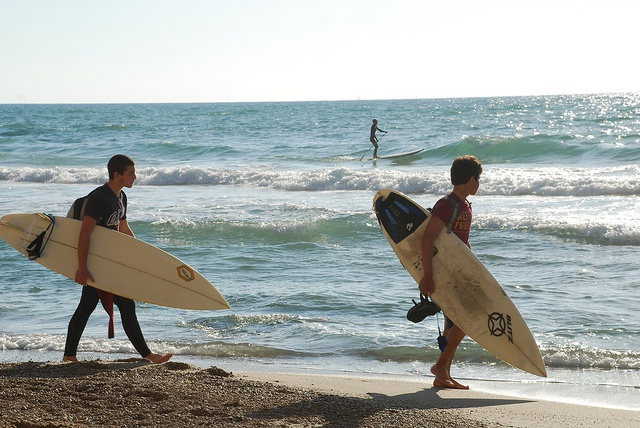Describe the objects in this image and their specific colors. I can see surfboard in white, gray, and black tones, surfboard in white, gray, and black tones, people in white, black, maroon, and gray tones, people in white, maroon, black, and gray tones, and people in white, black, gray, darkgray, and purple tones in this image. 